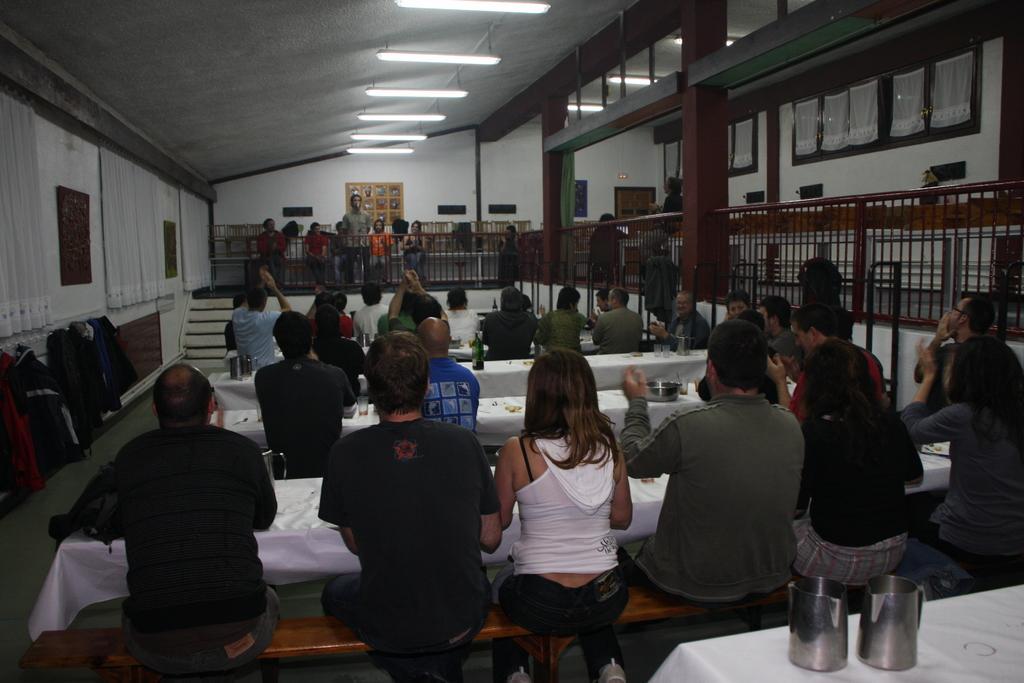Could you give a brief overview of what you see in this image? In the image there are people sitting on bench in front of table inside a building, in the back there are few people sitting and standing behind fence and there are lights over the ceiling. 